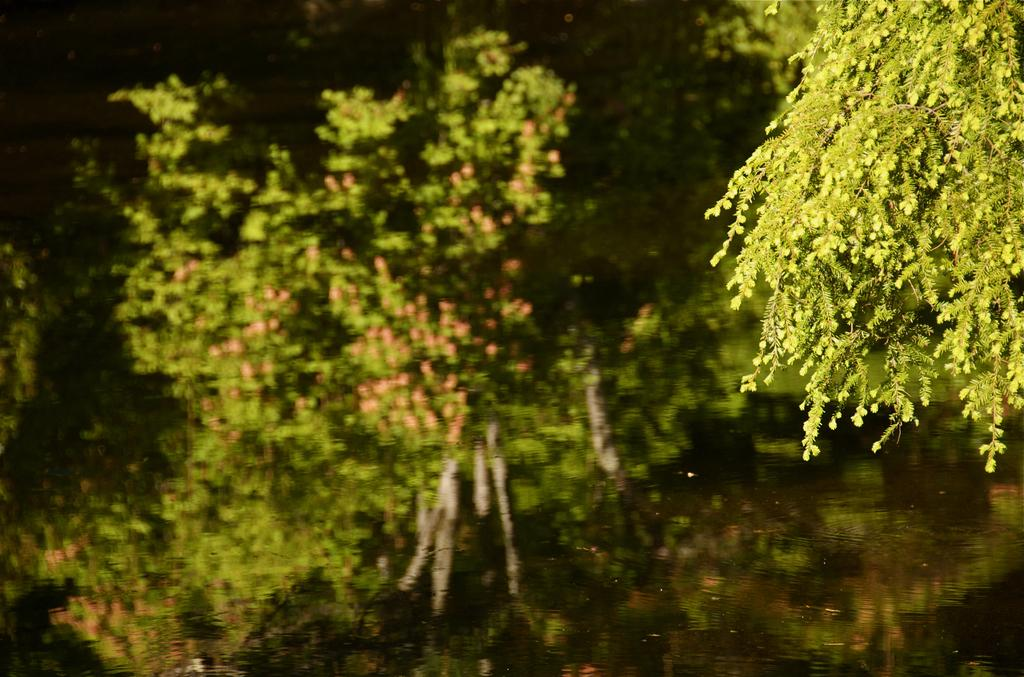What is located at the bottom of the image? There is a pond at the bottom of the image. What can be seen in the foreground of the image? There are plants in the foreground of the image. What is visible in the background of the image? There are plants in the background of the image. Where is the coal stored in the image? There is no coal present in the image. What type of ear is visible in the image? There are no ears visible in the image. 